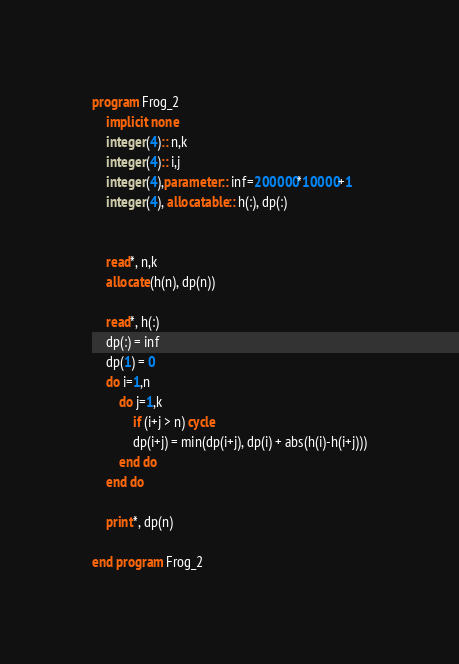Convert code to text. <code><loc_0><loc_0><loc_500><loc_500><_FORTRAN_>program Frog_2
    implicit none
    integer(4):: n,k
    integer(4):: i,j
    integer(4),parameter:: inf=200000*10000+1
    integer(4), allocatable:: h(:), dp(:)


    read*, n,k
    allocate(h(n), dp(n))

    read*, h(:)
    dp(:) = inf
    dp(1) = 0
    do i=1,n
        do j=1,k
            if (i+j > n) cycle
            dp(i+j) = min(dp(i+j), dp(i) + abs(h(i)-h(i+j)))
        end do
    end do

    print*, dp(n)

end program Frog_2</code> 